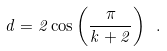Convert formula to latex. <formula><loc_0><loc_0><loc_500><loc_500>d = 2 \cos \left ( \frac { \pi } { k + 2 } \right ) \ .</formula> 